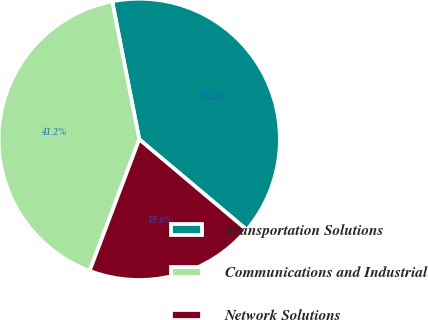Convert chart to OTSL. <chart><loc_0><loc_0><loc_500><loc_500><pie_chart><fcel>Transportation Solutions<fcel>Communications and Industrial<fcel>Network Solutions<nl><fcel>39.22%<fcel>41.18%<fcel>19.61%<nl></chart> 